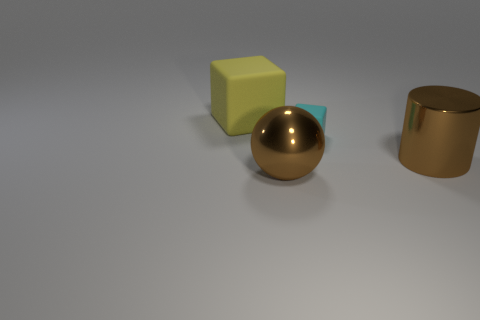How many matte cubes have the same color as the tiny rubber thing?
Your answer should be compact. 0. What number of tiny things are green metallic blocks or yellow things?
Keep it short and to the point. 0. Is the brown thing that is in front of the brown shiny cylinder made of the same material as the large yellow cube?
Your answer should be very brief. No. The matte cube in front of the big yellow rubber cube is what color?
Your answer should be compact. Cyan. Is there a red matte cylinder that has the same size as the metallic ball?
Ensure brevity in your answer.  No. What is the material of the ball that is the same size as the yellow matte cube?
Give a very brief answer. Metal. There is a cylinder; is its size the same as the rubber object right of the shiny ball?
Offer a terse response. No. There is a block right of the big matte block; what is its material?
Your answer should be compact. Rubber. Is the number of large brown metallic spheres on the left side of the large yellow rubber cube the same as the number of blue rubber objects?
Your answer should be compact. Yes. Is the size of the cylinder the same as the yellow rubber object?
Give a very brief answer. Yes. 